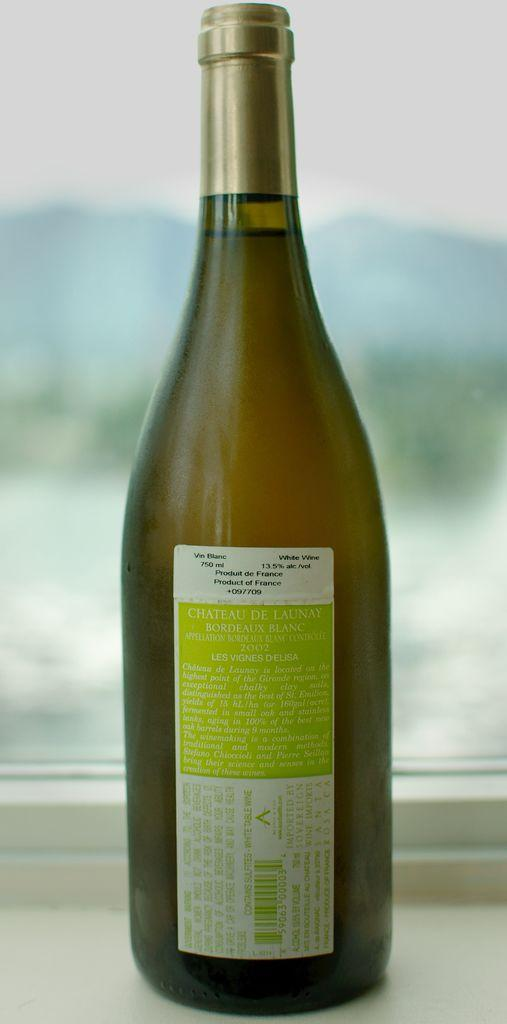<image>
Provide a brief description of the given image. the bottle of boudeaux blanc is sitting in front of a window, overlooking the maountain 